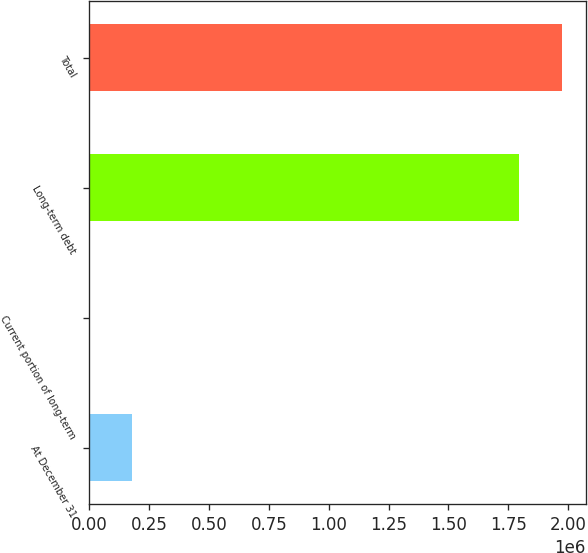Convert chart. <chart><loc_0><loc_0><loc_500><loc_500><bar_chart><fcel>At December 31<fcel>Current portion of long-term<fcel>Long-term debt<fcel>Total<nl><fcel>180428<fcel>914<fcel>1.79514e+06<fcel>1.97466e+06<nl></chart> 